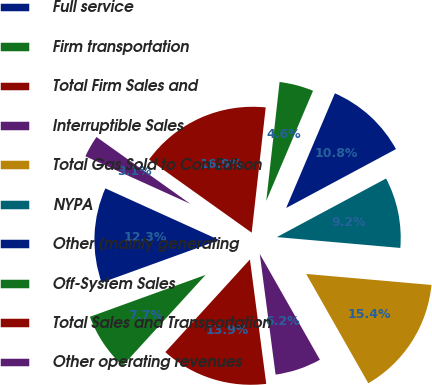Convert chart. <chart><loc_0><loc_0><loc_500><loc_500><pie_chart><fcel>Full service<fcel>Firm transportation<fcel>Total Firm Sales and<fcel>Interruptible Sales<fcel>Total Gas Sold to Con Edison<fcel>NYPA<fcel>Other (mainly generating<fcel>Off-System Sales<fcel>Total Sales and Transportation<fcel>Other operating revenues<nl><fcel>12.31%<fcel>7.69%<fcel>13.85%<fcel>6.15%<fcel>15.38%<fcel>9.23%<fcel>10.77%<fcel>4.62%<fcel>16.92%<fcel>3.08%<nl></chart> 